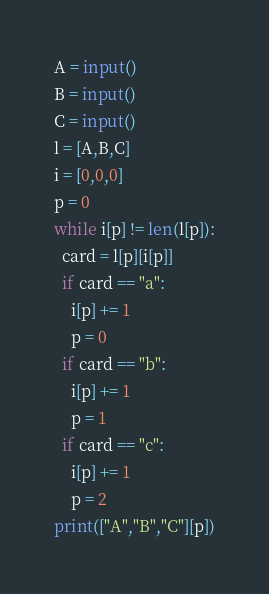Convert code to text. <code><loc_0><loc_0><loc_500><loc_500><_Python_>A = input()
B = input()
C = input()
l = [A,B,C]
i = [0,0,0]
p = 0
while i[p] != len(l[p]):
  card = l[p][i[p]] 
  if card == "a":
    i[p] += 1
    p = 0
  if card == "b":
    i[p] += 1
    p = 1
  if card == "c":
    i[p] += 1
    p = 2
print(["A","B","C"][p])</code> 